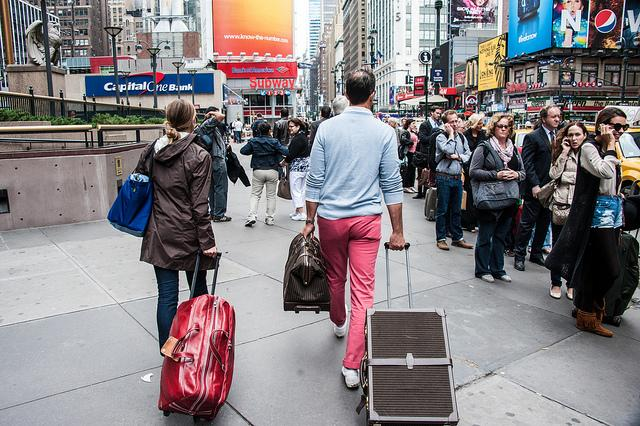The Red white and blue circular emblem on the visible billboard here advertises for what company?

Choices:
A) keds
B) pepsi
C) coke
D) bank america pepsi 